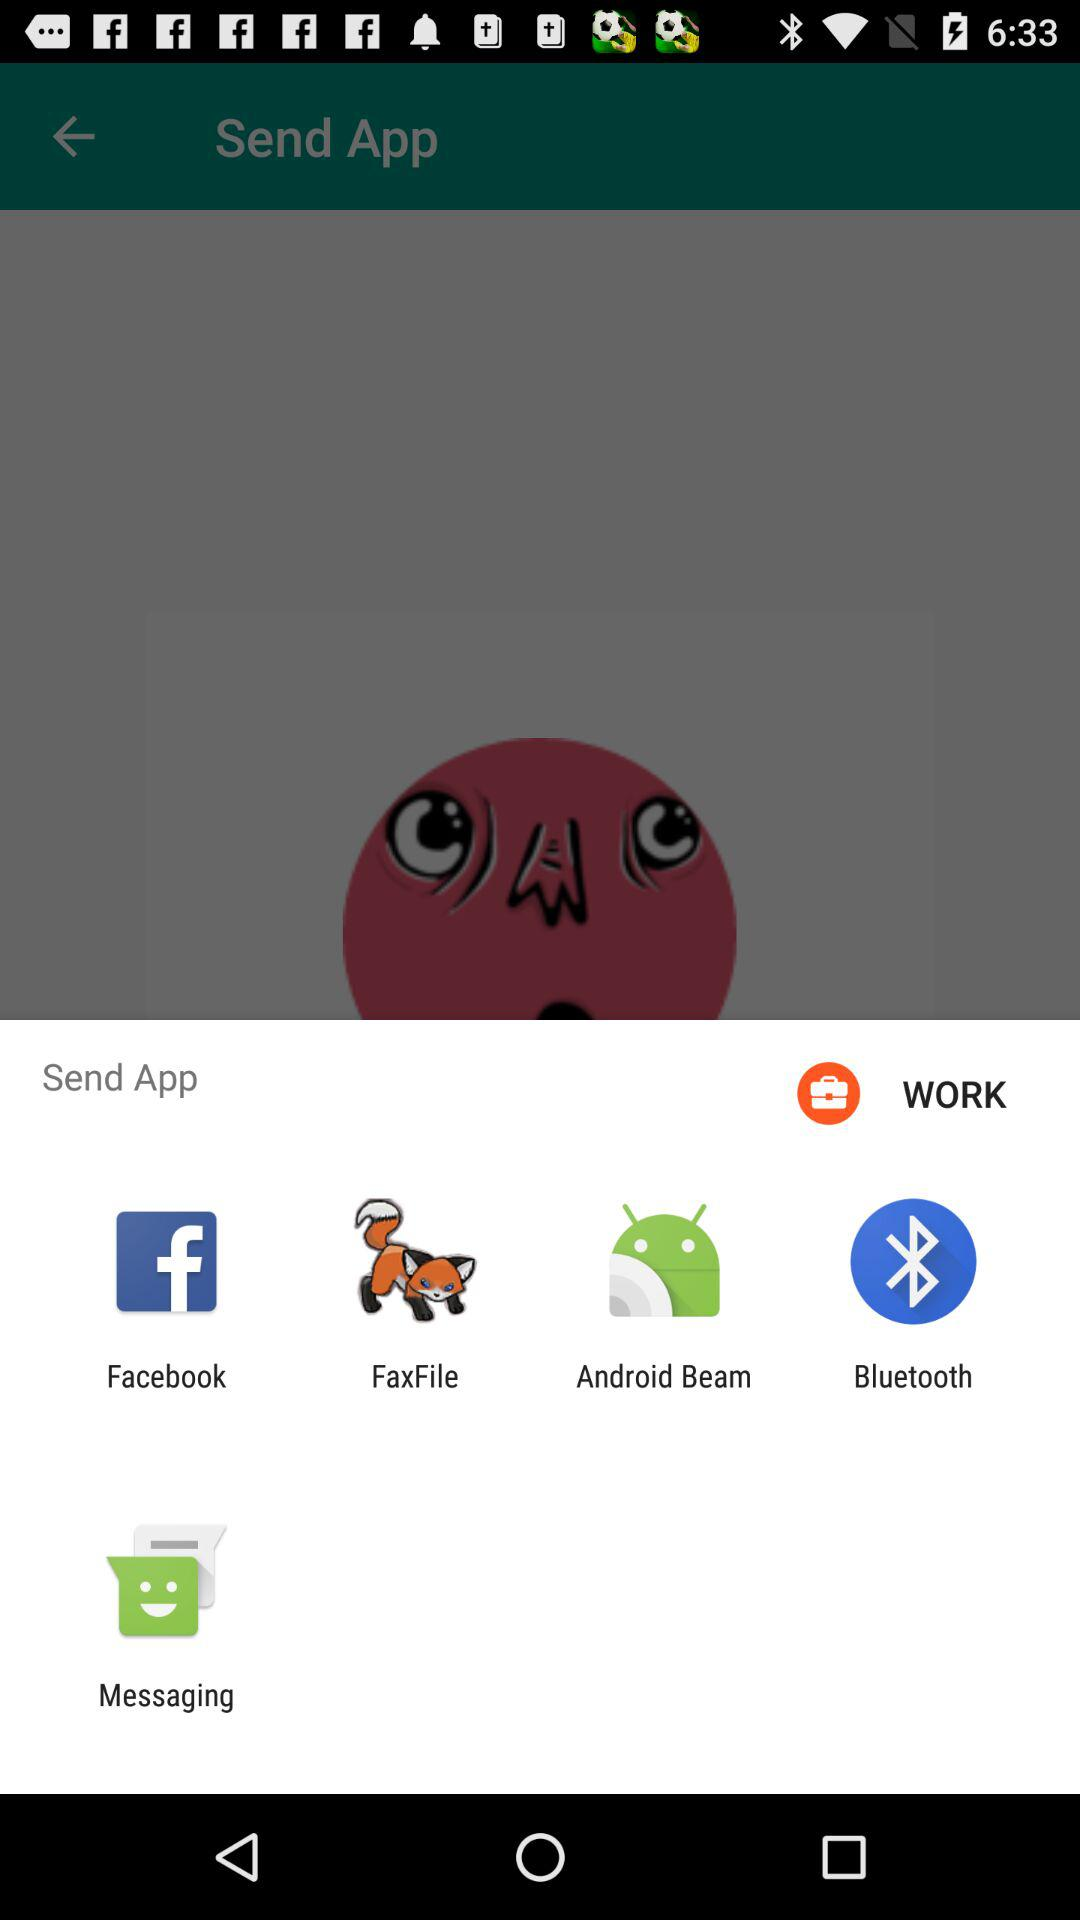What options are given to send an application? The given options are "Facebook", "FaxFile", "Android Beam", "Bluetooth" and "Messaging". 